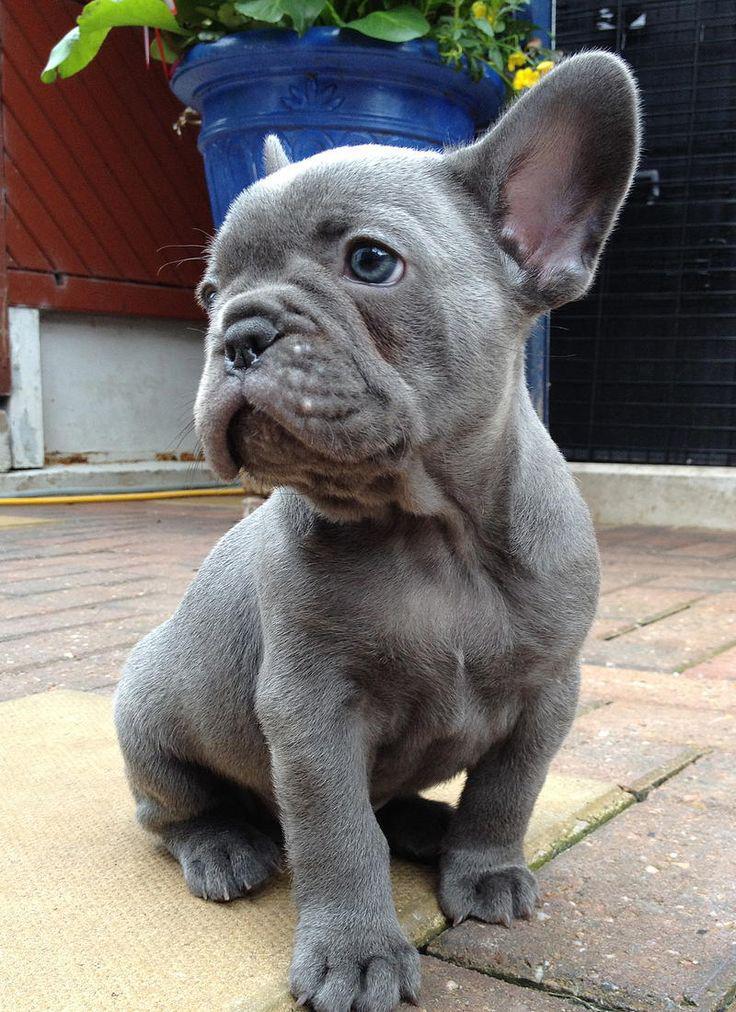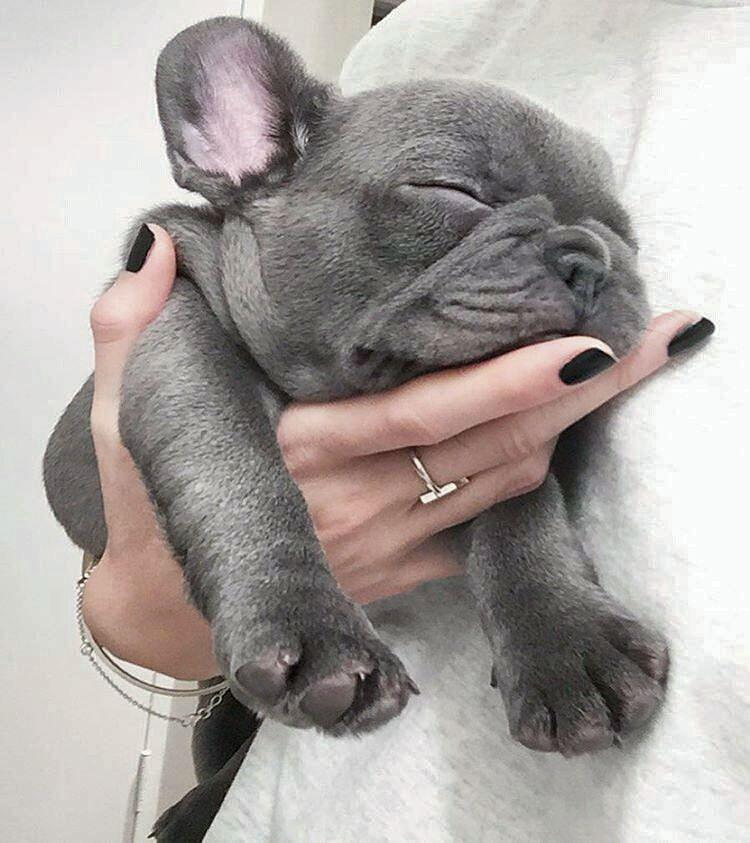The first image is the image on the left, the second image is the image on the right. Considering the images on both sides, is "At least one dog is sleeping next to a human." valid? Answer yes or no. Yes. The first image is the image on the left, the second image is the image on the right. For the images displayed, is the sentence "An adult human is holding one of the dogs." factually correct? Answer yes or no. Yes. 